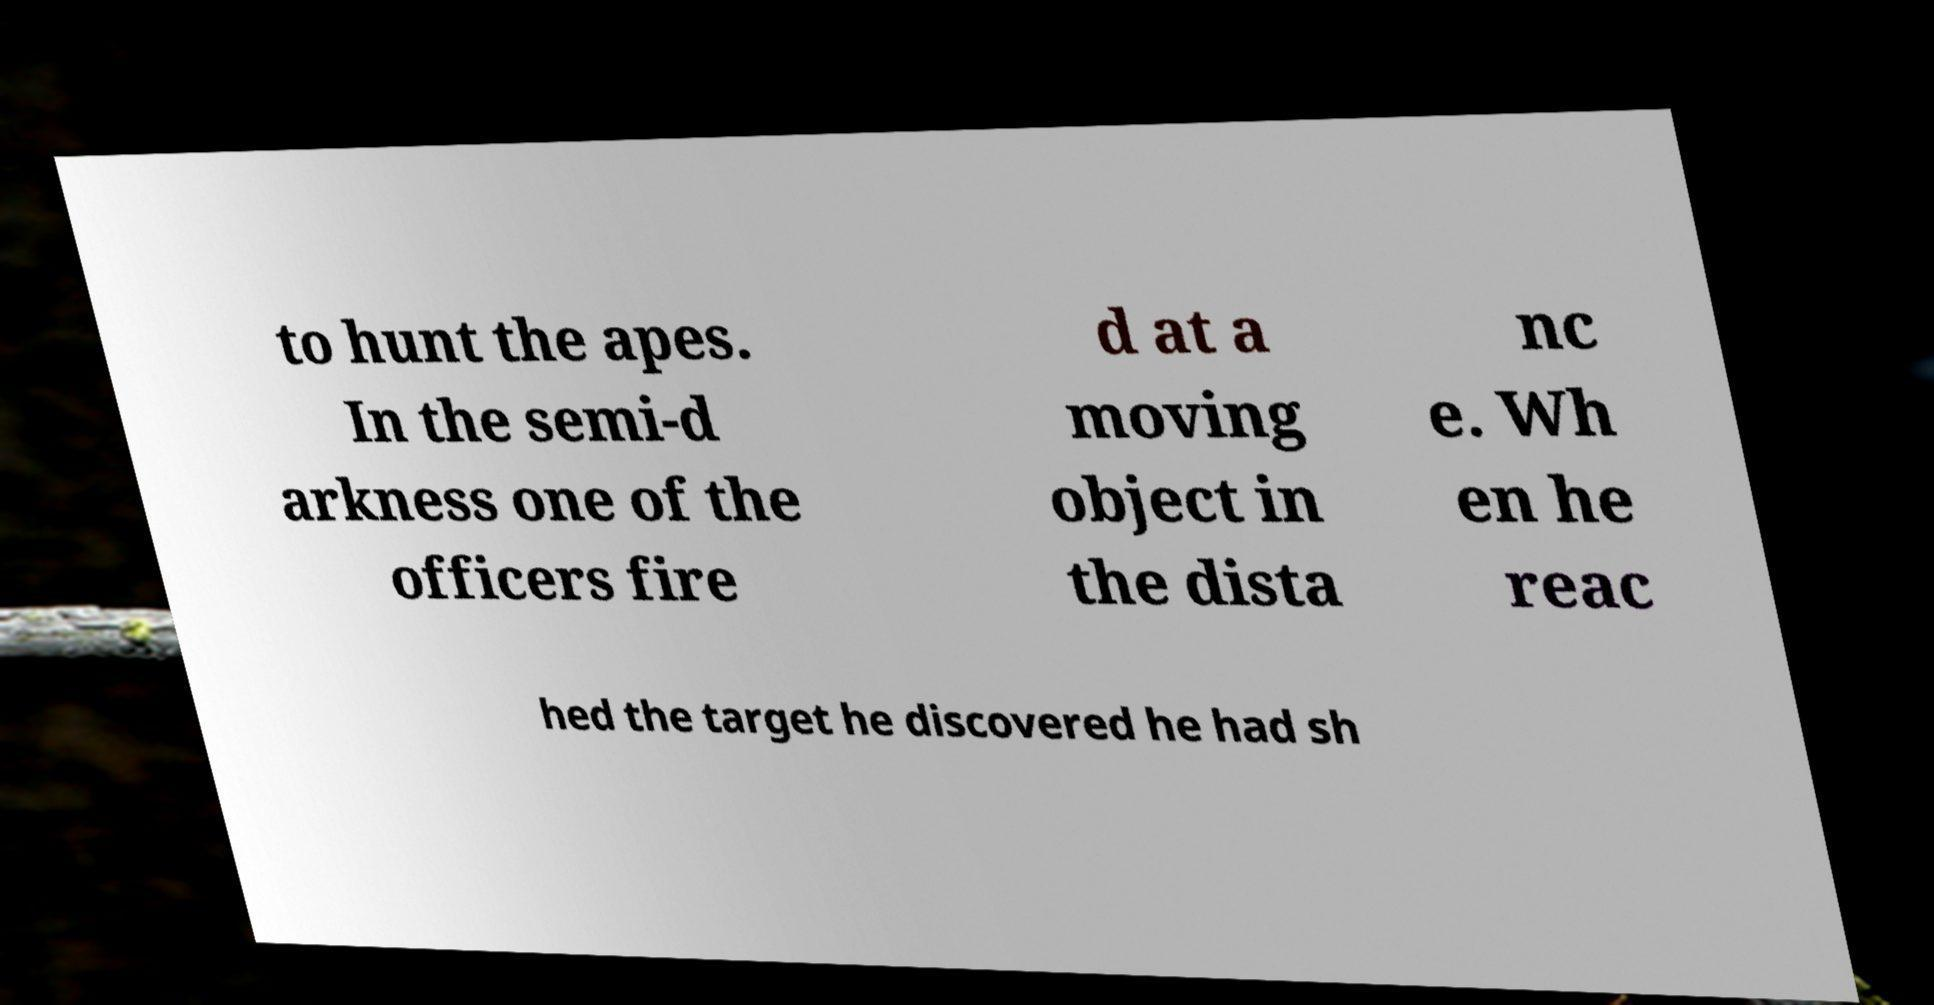There's text embedded in this image that I need extracted. Can you transcribe it verbatim? to hunt the apes. In the semi-d arkness one of the officers fire d at a moving object in the dista nc e. Wh en he reac hed the target he discovered he had sh 